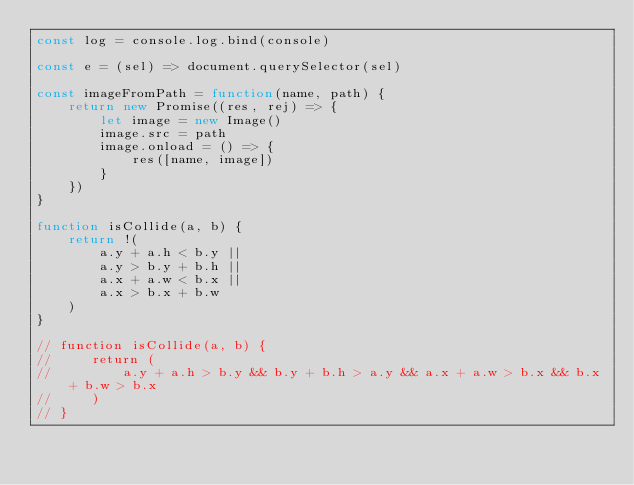<code> <loc_0><loc_0><loc_500><loc_500><_JavaScript_>const log = console.log.bind(console)

const e = (sel) => document.querySelector(sel)

const imageFromPath = function(name, path) {
    return new Promise((res, rej) => {
        let image = new Image()
        image.src = path
        image.onload = () => {
            res([name, image])
        }
    })
}

function isCollide(a, b) {
    return !(
        a.y + a.h < b.y ||
        a.y > b.y + b.h ||
        a.x + a.w < b.x ||
        a.x > b.x + b.w
    )
}

// function isCollide(a, b) {
//     return (
//         a.y + a.h > b.y && b.y + b.h > a.y && a.x + a.w > b.x && b.x + b.w > b.x
//     )
// }
</code> 